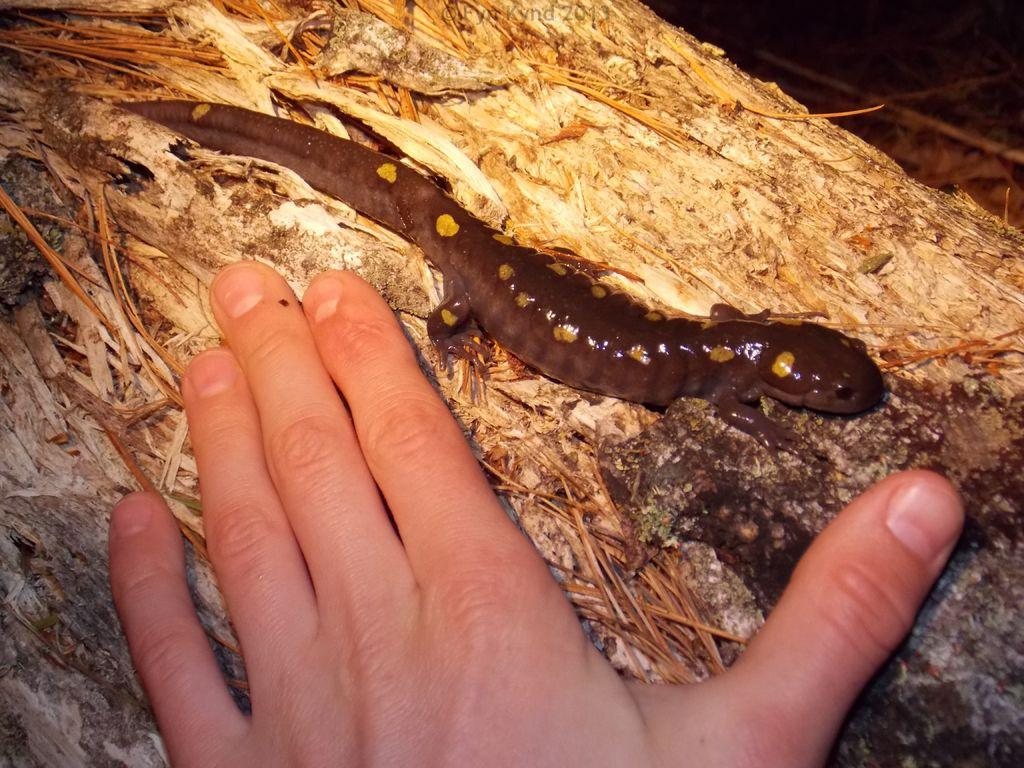What type of animal is in the image? There is a lizard in the image. Where is the lizard located? The lizard is on a surface. What else can be seen in the image? There is a hand visible in the image. What type of food is the lizard cooking in the image? There is no indication in the image that the lizard is cooking any food, as lizards do not have the ability to cook. 